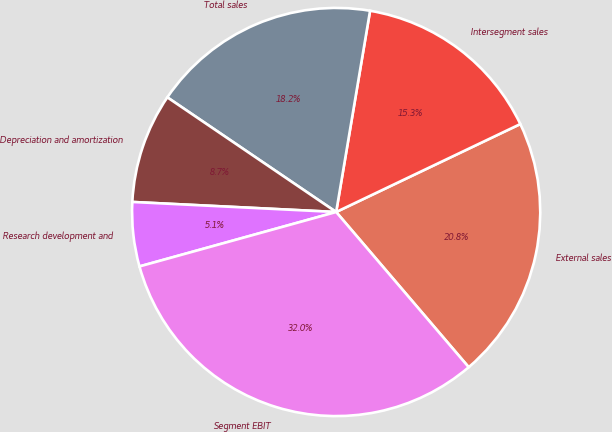Convert chart. <chart><loc_0><loc_0><loc_500><loc_500><pie_chart><fcel>External sales<fcel>Intersegment sales<fcel>Total sales<fcel>Depreciation and amortization<fcel>Research development and<fcel>Segment EBIT<nl><fcel>20.84%<fcel>15.25%<fcel>18.16%<fcel>8.71%<fcel>5.08%<fcel>31.95%<nl></chart> 